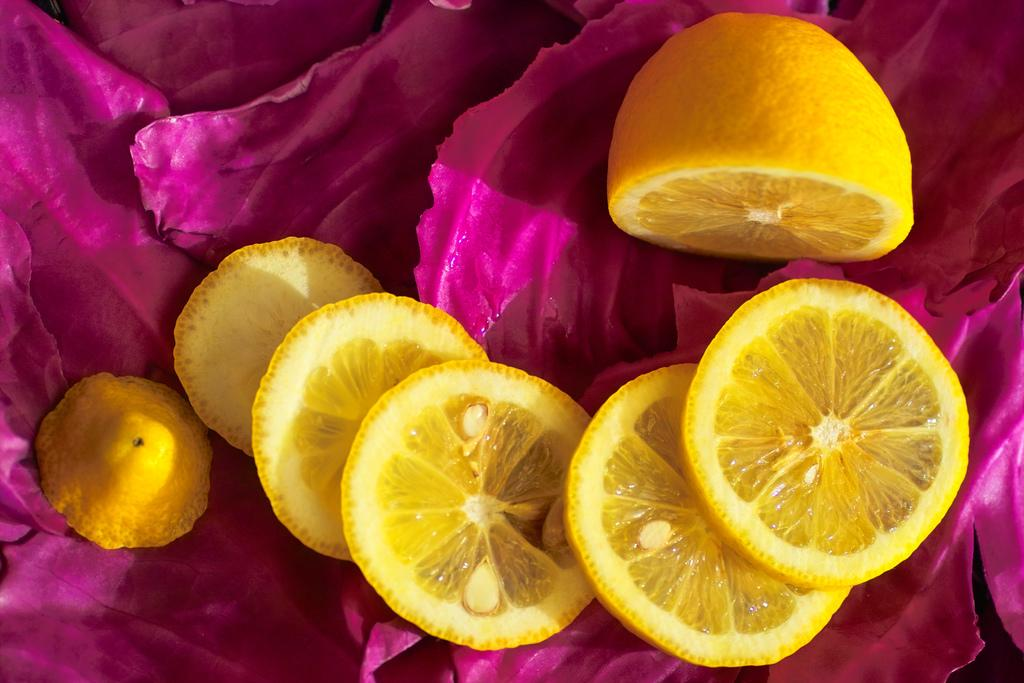What type of fruit is visible in the image? There are pieces of a lemon in the image. What color are the leaves in the image? The leaves in the image are dark pink. What type of experience can be seen in the image? There is no experience visible in the image; it only contains pieces of a lemon and dark pink leaves. How much debt is represented in the image? There is no debt represented in the image; it only contains pieces of a lemon and dark pink leaves. 